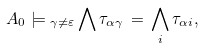Convert formula to latex. <formula><loc_0><loc_0><loc_500><loc_500>A _ { 0 } \models { _ { \gamma \neq \varepsilon } } \bigwedge \tau _ { \alpha \gamma } \, = \, \bigwedge _ { i } \tau _ { \alpha i } ,</formula> 